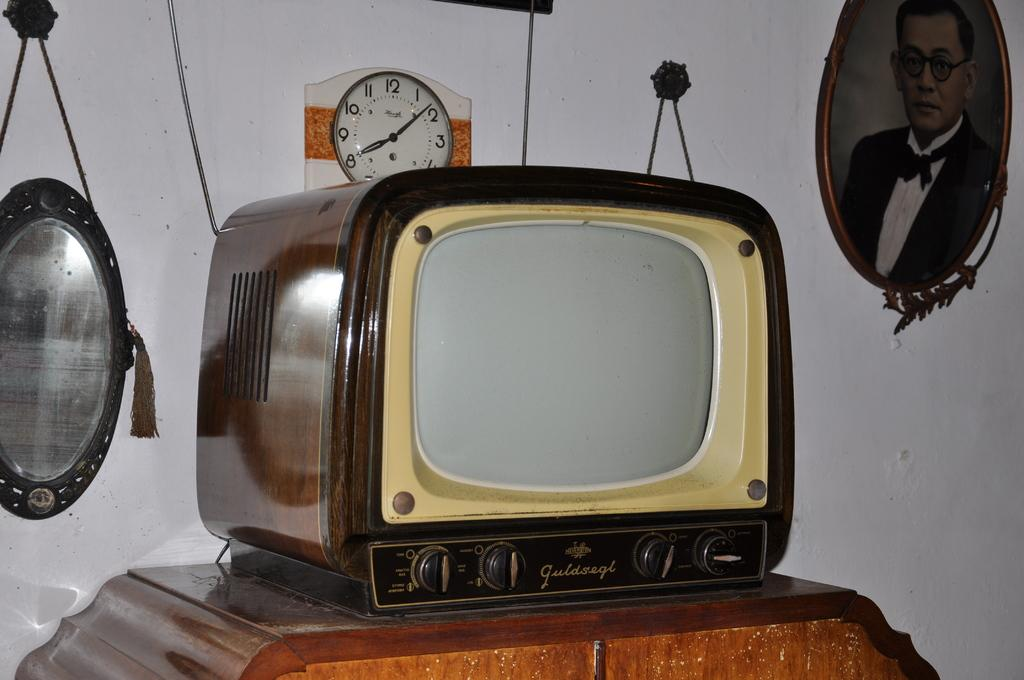Provide a one-sentence caption for the provided image. A Guldsegl brand TV is atop a wooden table. 